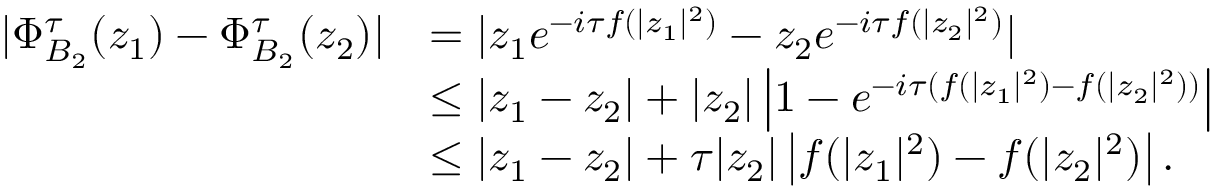Convert formula to latex. <formula><loc_0><loc_0><loc_500><loc_500>\begin{array} { r l } { | \Phi _ { B _ { 2 } } ^ { \tau } ( z _ { 1 } ) - \Phi _ { B _ { 2 } } ^ { \tau } ( z _ { 2 } ) | } & { = | z _ { 1 } e ^ { - i \tau f ( | z _ { 1 } | ^ { 2 } ) } - z _ { 2 } e ^ { - i \tau f ( | z _ { 2 } | ^ { 2 } ) } | } \\ & { \leq | z _ { 1 } - z _ { 2 } | + | z _ { 2 } | \left | 1 - e ^ { - i \tau ( f ( | z _ { 1 } | ^ { 2 } ) - f ( | z _ { 2 } | ^ { 2 } ) ) } \right | } \\ & { \leq | z _ { 1 } - z _ { 2 } | + \tau | z _ { 2 } | \left | f ( | z _ { 1 } | ^ { 2 } ) - f ( | z _ { 2 } | ^ { 2 } ) \right | . } \end{array}</formula> 